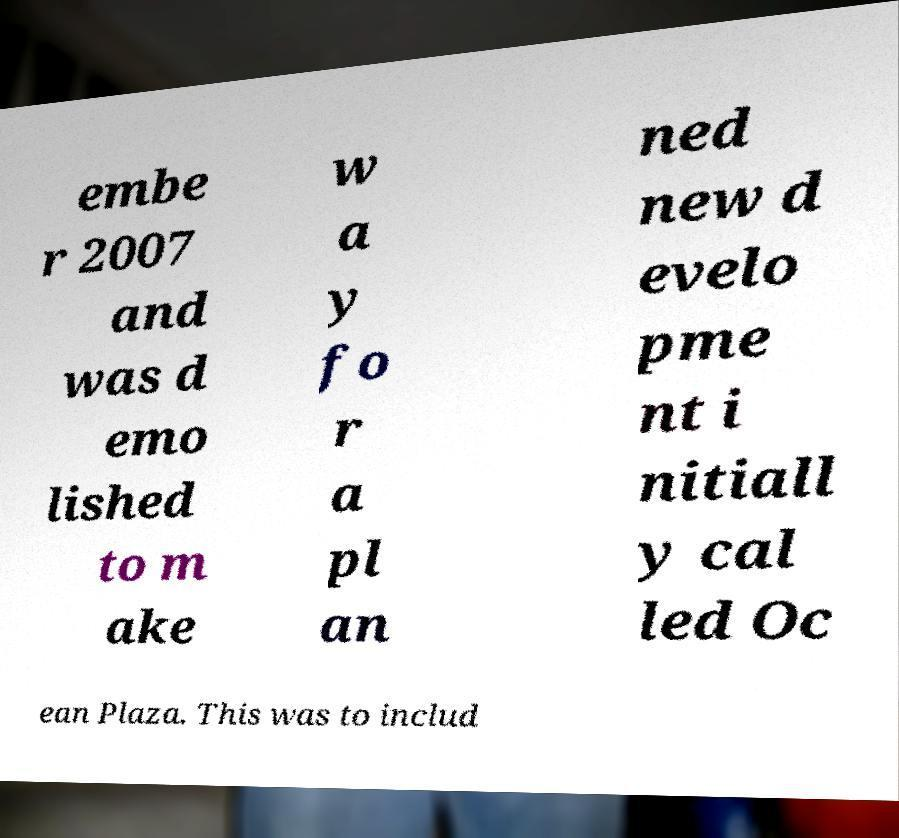Could you assist in decoding the text presented in this image and type it out clearly? embe r 2007 and was d emo lished to m ake w a y fo r a pl an ned new d evelo pme nt i nitiall y cal led Oc ean Plaza. This was to includ 